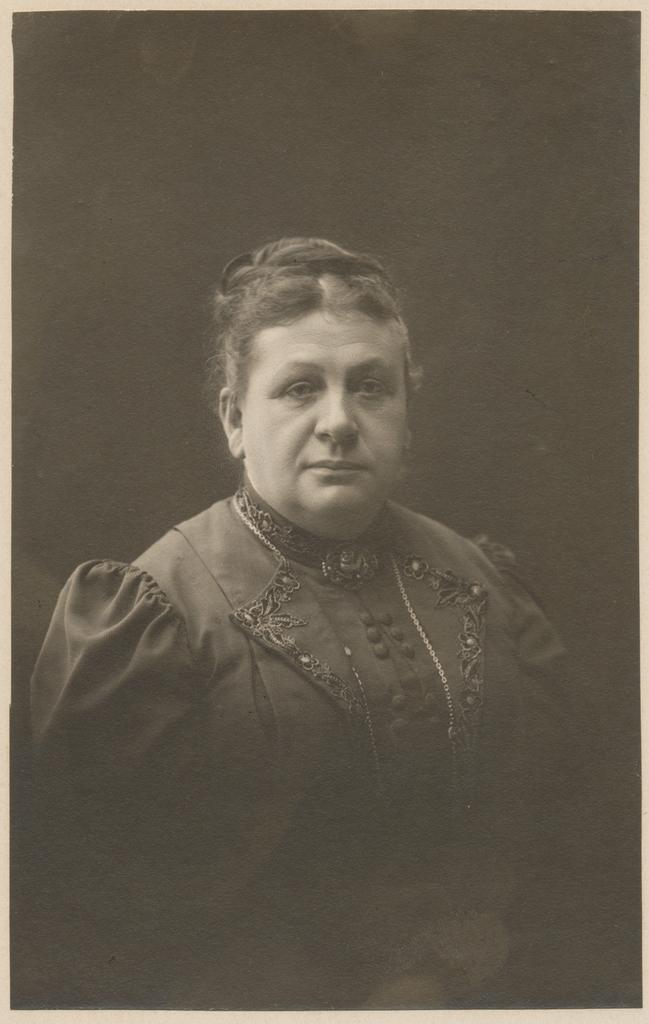What can be said about the age of the picture? The picture is old. What color scheme is used in the picture? The picture is black and white. Who is in the picture? There is a woman in the picture. What type of clothing is the woman wearing? The woman is wearing a traditional dress. How many buns can be seen in the woman's hair in the picture? There is no indication of buns in the woman's hair in the picture, as it is black and white and does not show details of her hairstyle. 